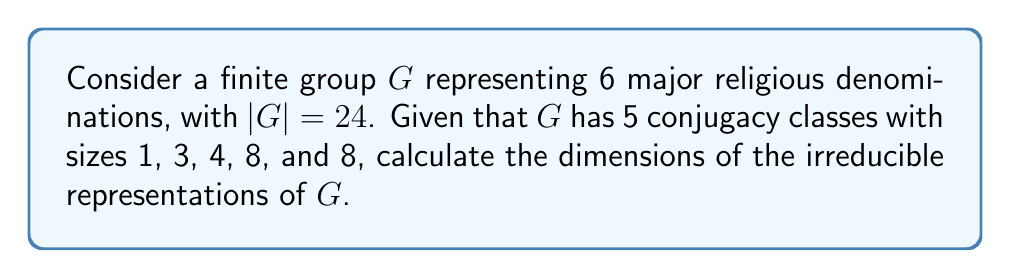Solve this math problem. To solve this problem, we'll use the following steps:

1) Recall that for a finite group $G$, the number of irreducible representations is equal to the number of conjugacy classes. Here, we have 5 conjugacy classes, so there are 5 irreducible representations.

2) Let the dimensions of these irreducible representations be $d_1, d_2, d_3, d_4,$ and $d_5$.

3) We can use the formula:

   $$\sum_{i=1}^k d_i^2 = |G|$$

   where $k$ is the number of irreducible representations and $|G|$ is the order of the group.

4) Substituting our known values:

   $$d_1^2 + d_2^2 + d_3^2 + d_4^2 + d_5^2 = 24$$

5) We also know that every finite group has a 1-dimensional trivial representation. So, $d_1 = 1$.

6) Now our equation becomes:

   $$1 + d_2^2 + d_3^2 + d_4^2 + d_5^2 = 24$$

7) The sizes of the conjugacy classes (1, 3, 4, 8, 8) give us a clue about the other dimensions. The sum of squares of the dimensions must equal the order of the group, and each dimension must divide the order of the group.

8) Given these constraints, the only possible solution is:

   $$1^2 + 1^2 + 2^2 + 2^2 + 4^2 = 1 + 1 + 4 + 4 + 16 = 24$$

Therefore, the dimensions of the irreducible representations are 1, 1, 2, 2, and 4.
Answer: $d_1 = 1, d_2 = 1, d_3 = 2, d_4 = 2, d_5 = 4$ 